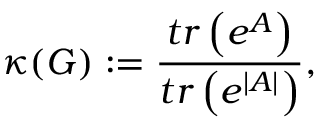Convert formula to latex. <formula><loc_0><loc_0><loc_500><loc_500>\kappa ( G ) \colon = \frac { t r \left ( e ^ { A } \right ) } { t r \left ( e ^ { \left | A \right | } \right ) } ,</formula> 